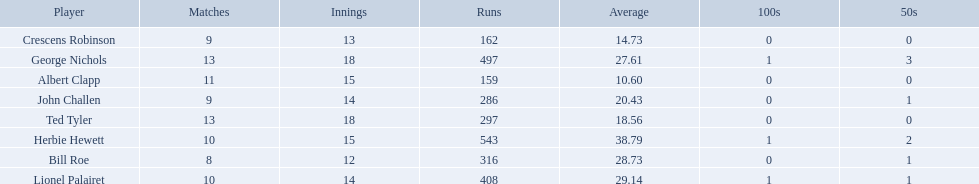Who are all of the players? Herbie Hewett, Lionel Palairet, Bill Roe, George Nichols, John Challen, Ted Tyler, Crescens Robinson, Albert Clapp. How many innings did they play in? 15, 14, 12, 18, 14, 18, 13, 15. Which player was in fewer than 13 innings? Bill Roe. 